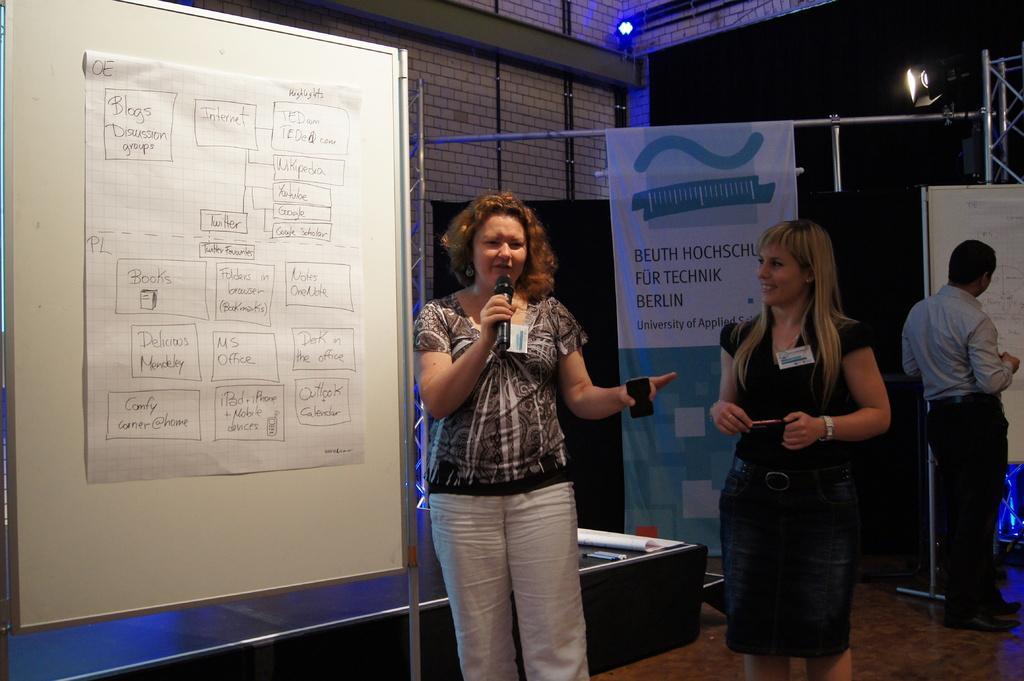In one or two sentences, can you explain what this image depicts? In this picture I can observe two women standing on the floor. One of them is holding a mic in her hand. On the left side I can observe a chart on the white color board. In the background I can observe a wall. 